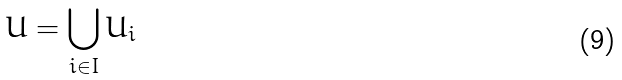<formula> <loc_0><loc_0><loc_500><loc_500>U = \bigcup _ { i \in I } U _ { i }</formula> 